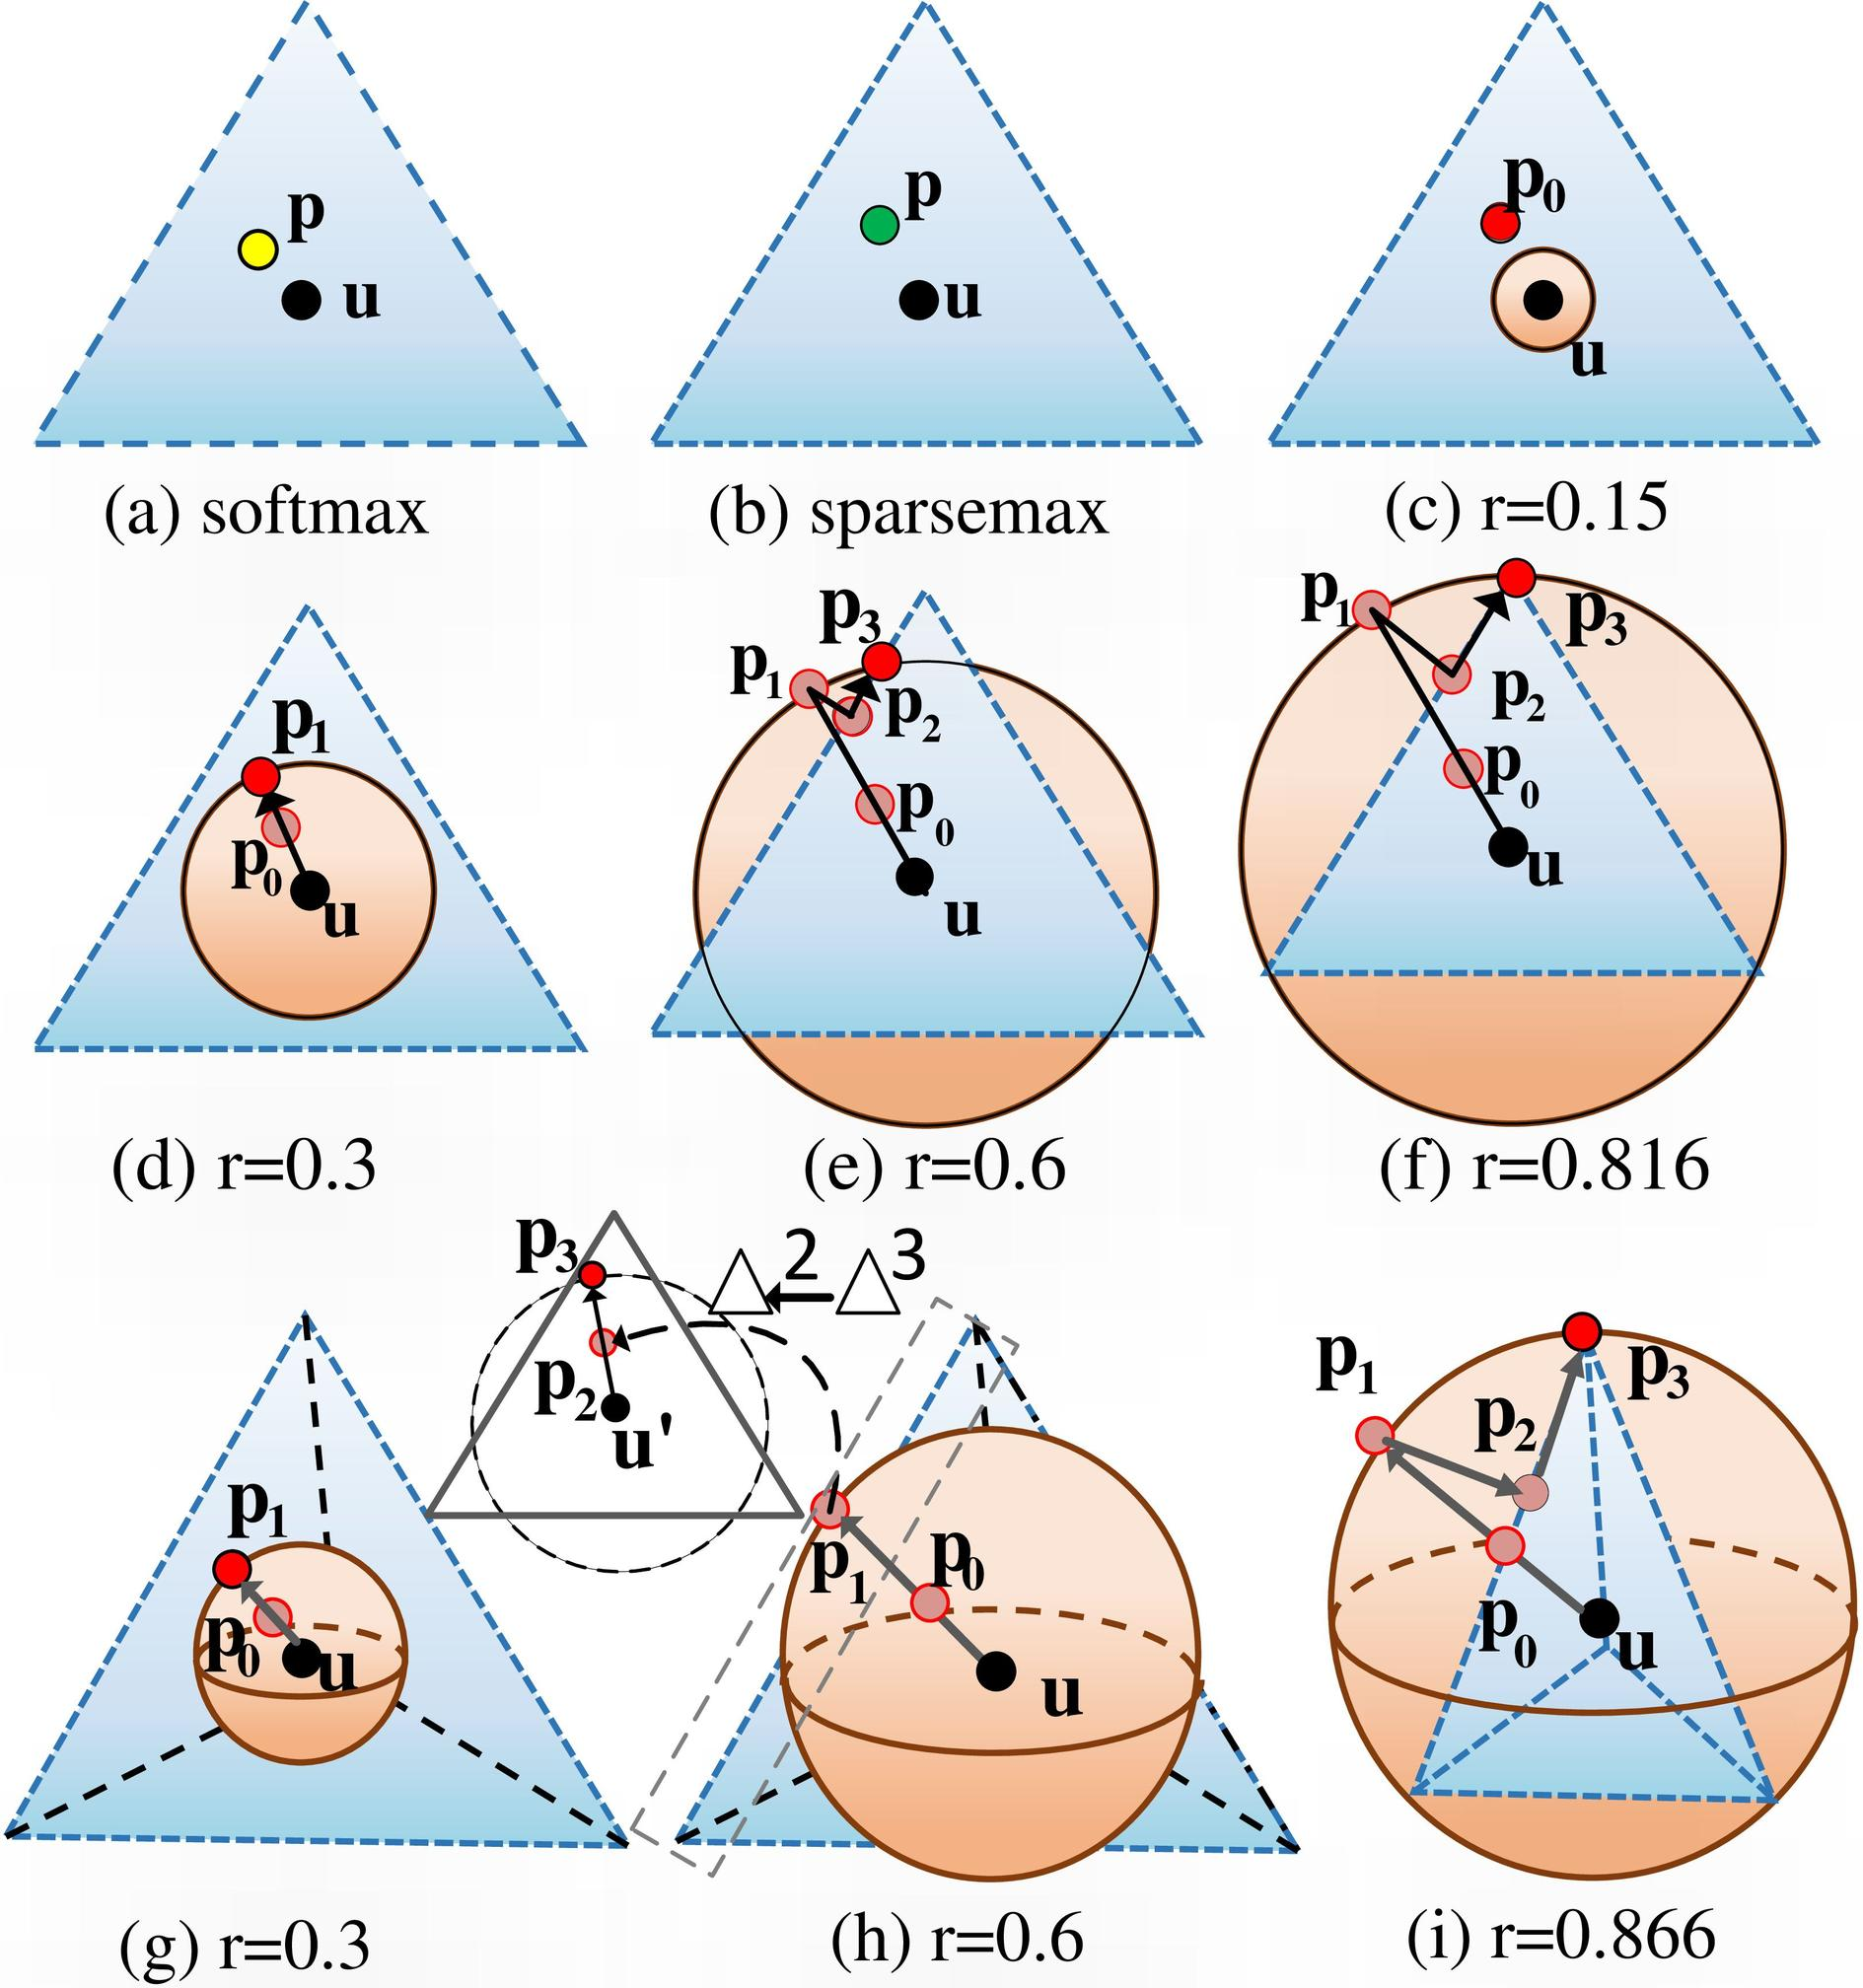Based on the figures (d) to (i), which value of r demonstrates the largest entropic regularization effect on the distribution? A. r=0.15 B. r=0.3 C. r=0.6 D. r=0.816 The entropic regularization effect is indicated by the spread of the probability distribution around point u. In figure (f), where r=0.816, the probability distribution (represented by the shaded area) is the most spread out, indicating the largest entropic regularization effect. Therefore, the correct answer is D. 